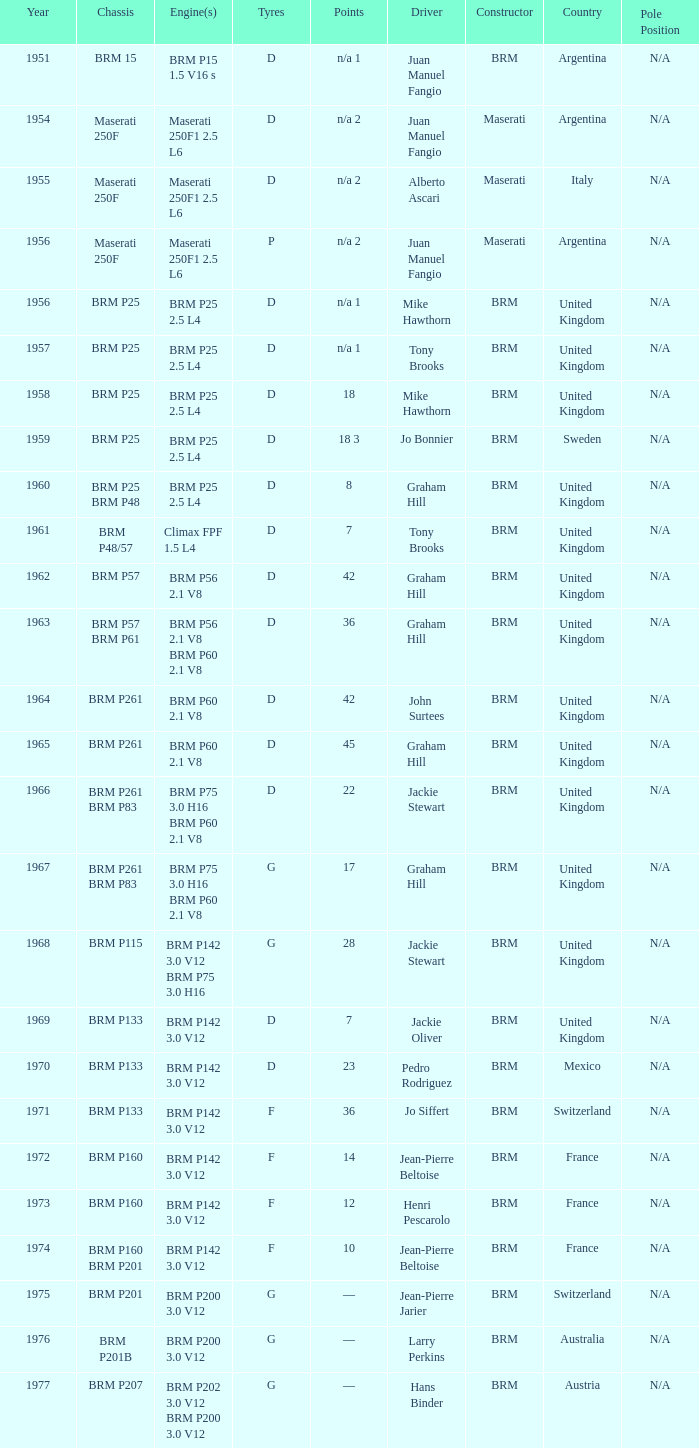Name the chassis of 1961 BRM P48/57. 